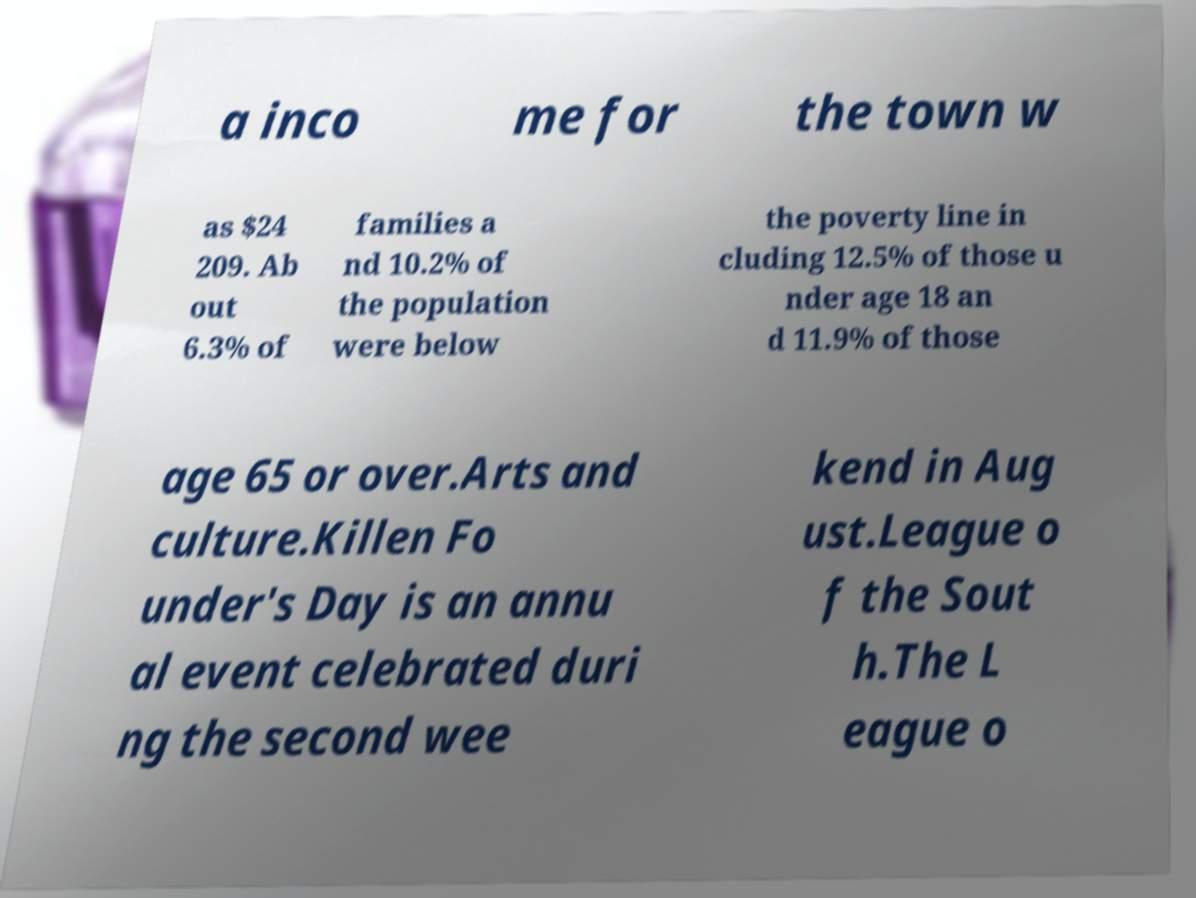For documentation purposes, I need the text within this image transcribed. Could you provide that? a inco me for the town w as $24 209. Ab out 6.3% of families a nd 10.2% of the population were below the poverty line in cluding 12.5% of those u nder age 18 an d 11.9% of those age 65 or over.Arts and culture.Killen Fo under's Day is an annu al event celebrated duri ng the second wee kend in Aug ust.League o f the Sout h.The L eague o 